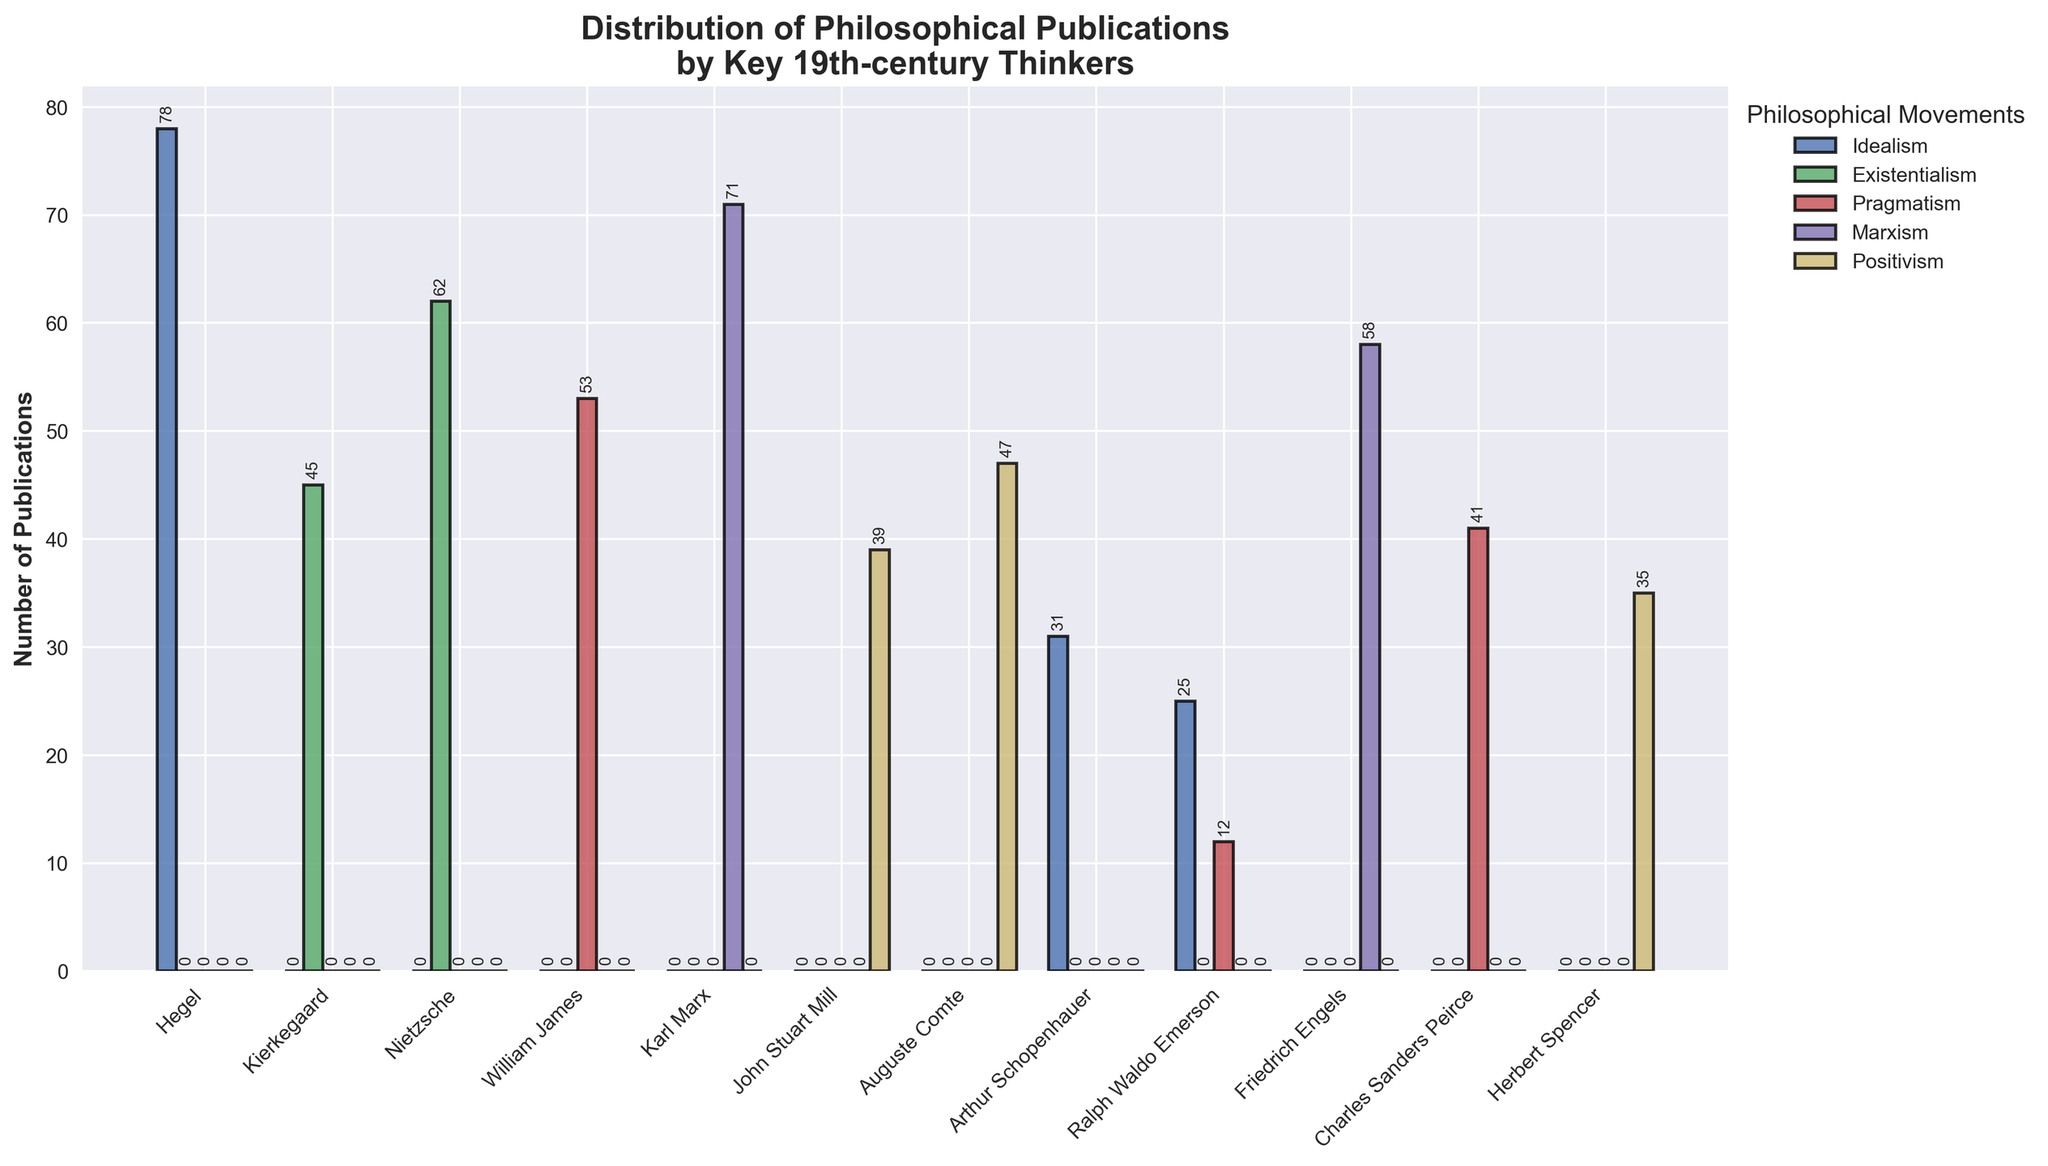What is the total number of publications attributed to Hegel? To find the total number of publications for Hegel, we only need to look at the value under Idealism, which is 78. There are no publications under any other movement for Hegel.
Answer: 78 How many more publications does Nietzsche have in Existentialism compared to Kierkegaard? Nietzsche has 62 publications in Existentialism, while Kierkegaard has 45. The difference is 62 - 45 = 17.
Answer: 17 Which philosopher has the highest number of publications in Pragmatism? The philosophers listed under Pragmatism are William James (53), Ralph Waldo Emerson (12), and Charles Sanders Peirce (41). William James has the highest number with 53 publications.
Answer: William James Are there any philosophers who have publications in more than one philosophical movement? The only philosopher with publications in more than one movement is Ralph Waldo Emerson, who has publications in both Idealism (25) and Pragmatism (12).
Answer: Ralph Waldo Emerson What is the combined total of publications for Marx and Engels in Marxism? Karl Marx has 71 publications and Friedrich Engels has 58 publications in Marxism. Adding these gives 71 + 58 = 129.
Answer: 129 Who has more publications in Positivism, John Stuart Mill or Herbert Spencer? The number of publications in Positivism for John Stuart Mill is 39, while for Herbert Spencer it is 35. John Stuart Mill has more publications.
Answer: John Stuart Mill What is the difference in the number of publications between Hegel in Idealism and Nietzsche in Existentialism? Hegel has 78 publications in Idealism, and Nietzsche has 62 in Existentialism. The difference is 78 - 62 = 16.
Answer: 16 Which philosophical movement has the most publications overall in the dataset? To determine this, sum the values for each movement:
Idealism: 78+31+25 = 134,
Existentialism: 45+62 = 107,
Pragmatism: 53+12+41 = 106,
Marxism: 71+58 = 129,
Positivism: 39+47+35 = 121.
Idealism has the most publications with a total of 134.
Answer: Idealism 